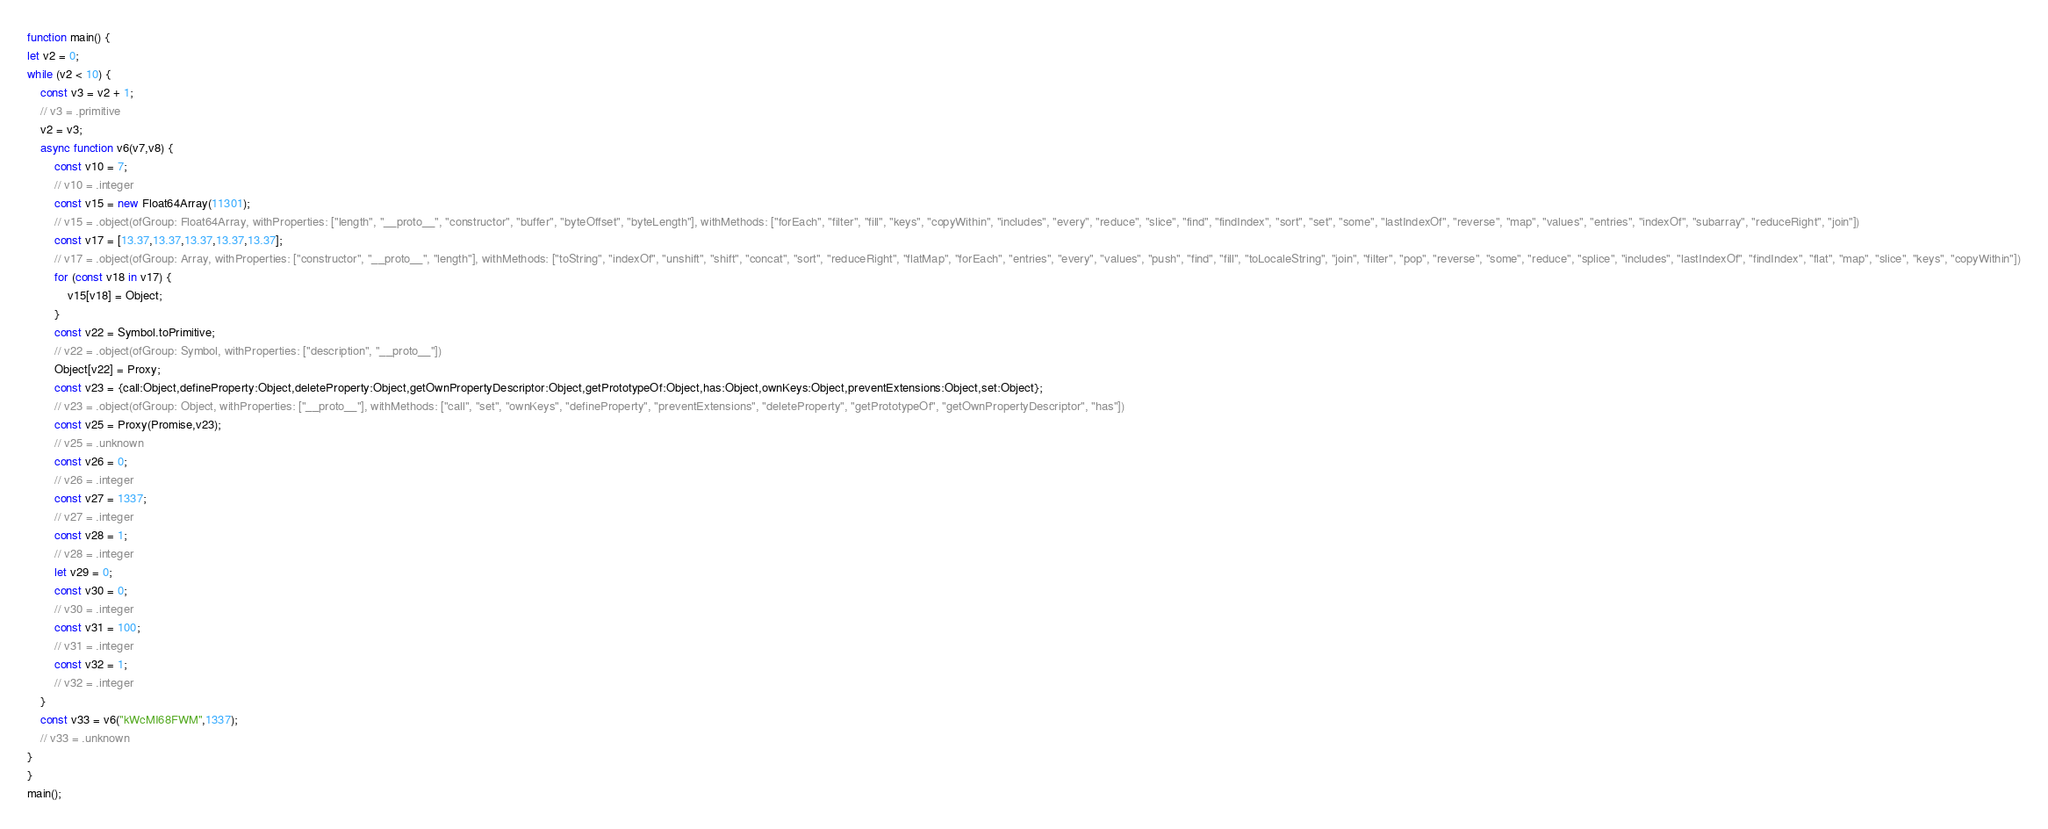<code> <loc_0><loc_0><loc_500><loc_500><_JavaScript_>function main() {
let v2 = 0;
while (v2 < 10) {
    const v3 = v2 + 1;
    // v3 = .primitive
    v2 = v3;
    async function v6(v7,v8) {
        const v10 = 7;
        // v10 = .integer
        const v15 = new Float64Array(11301);
        // v15 = .object(ofGroup: Float64Array, withProperties: ["length", "__proto__", "constructor", "buffer", "byteOffset", "byteLength"], withMethods: ["forEach", "filter", "fill", "keys", "copyWithin", "includes", "every", "reduce", "slice", "find", "findIndex", "sort", "set", "some", "lastIndexOf", "reverse", "map", "values", "entries", "indexOf", "subarray", "reduceRight", "join"])
        const v17 = [13.37,13.37,13.37,13.37,13.37];
        // v17 = .object(ofGroup: Array, withProperties: ["constructor", "__proto__", "length"], withMethods: ["toString", "indexOf", "unshift", "shift", "concat", "sort", "reduceRight", "flatMap", "forEach", "entries", "every", "values", "push", "find", "fill", "toLocaleString", "join", "filter", "pop", "reverse", "some", "reduce", "splice", "includes", "lastIndexOf", "findIndex", "flat", "map", "slice", "keys", "copyWithin"])
        for (const v18 in v17) {
            v15[v18] = Object;
        }
        const v22 = Symbol.toPrimitive;
        // v22 = .object(ofGroup: Symbol, withProperties: ["description", "__proto__"])
        Object[v22] = Proxy;
        const v23 = {call:Object,defineProperty:Object,deleteProperty:Object,getOwnPropertyDescriptor:Object,getPrototypeOf:Object,has:Object,ownKeys:Object,preventExtensions:Object,set:Object};
        // v23 = .object(ofGroup: Object, withProperties: ["__proto__"], withMethods: ["call", "set", "ownKeys", "defineProperty", "preventExtensions", "deleteProperty", "getPrototypeOf", "getOwnPropertyDescriptor", "has"])
        const v25 = Proxy(Promise,v23);
        // v25 = .unknown
        const v26 = 0;
        // v26 = .integer
        const v27 = 1337;
        // v27 = .integer
        const v28 = 1;
        // v28 = .integer
        let v29 = 0;
        const v30 = 0;
        // v30 = .integer
        const v31 = 100;
        // v31 = .integer
        const v32 = 1;
        // v32 = .integer
    }
    const v33 = v6("kWcMI68FWM",1337);
    // v33 = .unknown
}
}
main();

</code> 